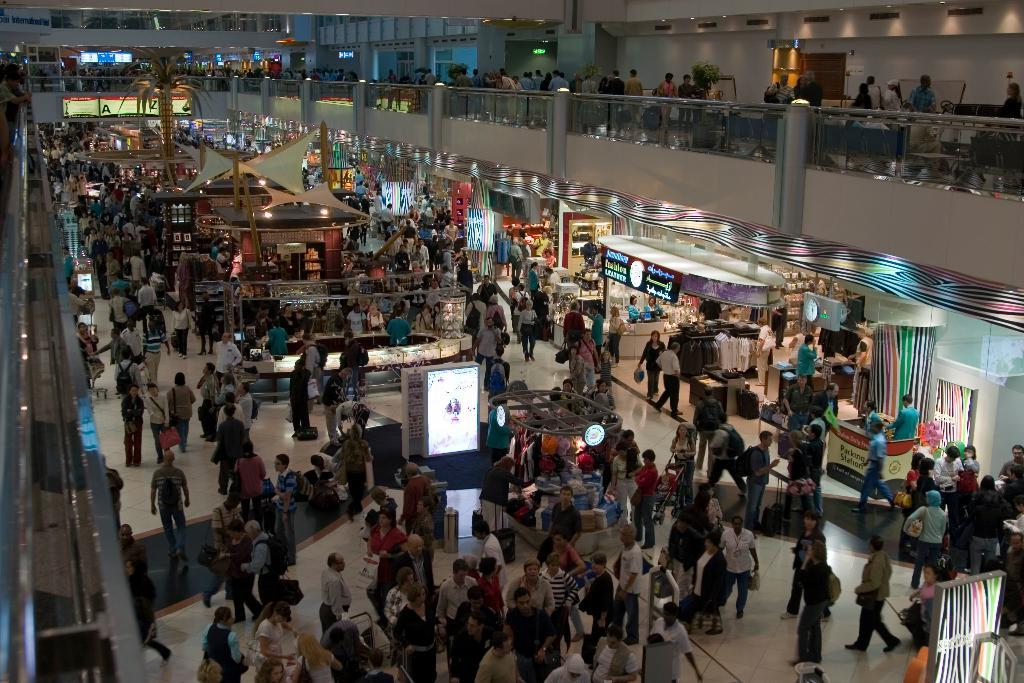How many people can be seen in the image? There are persons in the image, but the exact number cannot be determined from the provided facts. What type of establishments are present in the image? There are stores in the image. What additional features can be seen in the image? Advertisements, cloth, lights, a tree, stairs, pillars, doors, and a wall are present in the image. What type of toothpaste is being advertised on the wall in the image? There is no toothpaste being advertised in the image; the provided facts only mention the presence of advertisements in general. Can you describe the honeycomb structure visible in the image? There is no honeycomb structure present in the image; the provided facts mention a tree, but not a honeycomb. 